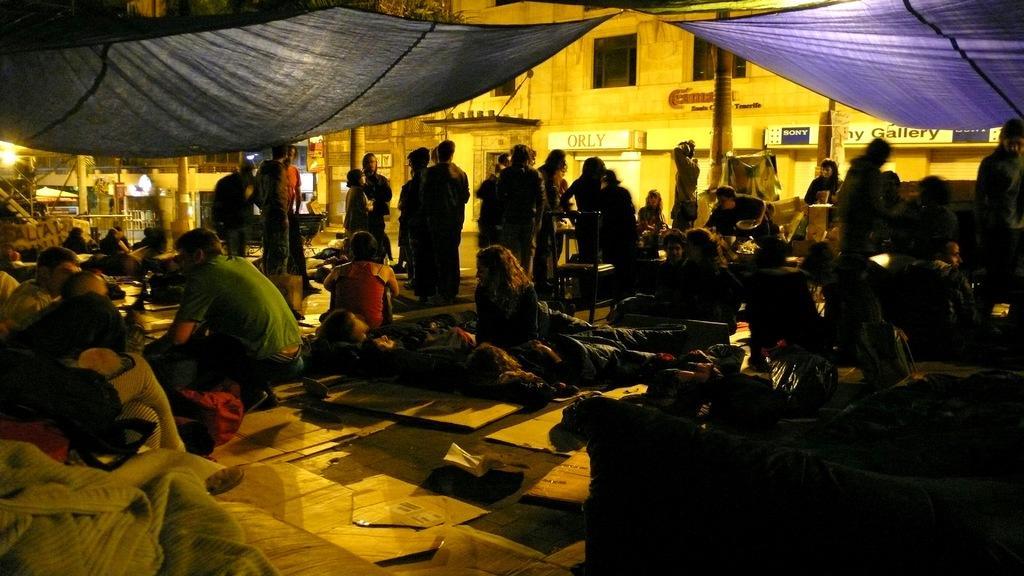Describe this image in one or two sentences. In this image we can see few people are sitting on the ground, few people are lying on the ground and few people are standing. Here we can see chairs, tents, trees, boards and buildings in the background. 